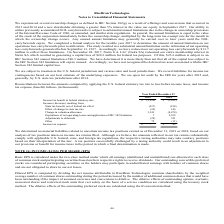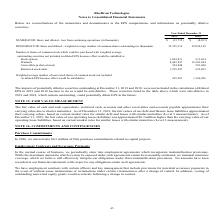From Ricebran Technologies's financial document, What are the respective basic and diluted - loss from continuing operations in 2018 and 2019? The document shows two values: 8,101 and 13,735 (in thousands). From the document: "- loss from continuing operations (in thousands) (13,735) $ (8,101) $ continuing operations (in thousands) (13,735) $ (8,101) $..." Also, What are the respective basic and diluted - weighted average number of common shares outstanding in 2018 and 2019? The document shows two values: 22,099,149 and 32,359,316 (in thousands). From the document: "mmon shares outstanding (in thousands) 32,359,316 22,099,149 umber of common shares outstanding (in thousands) 32,359,316 22,099,149..." Also, What are the respective number of stock options in 2018 and 2019? The document shows two values: 911,264 and 1,024,811 (in thousands). From the document: "Stock options 1,024,811 911,264 Stock options 1,024,811 911,264..." Also, can you calculate: What is the average number of stock options between 2018 and 2019? To answer this question, I need to perform calculations using the financial data. The calculation is: (911,264 + 1,024,811)/2 , which equals 968037.5. This is based on the information: "Stock options 1,024,811 911,264 Stock options 1,024,811 911,264..." The key data points involved are: 1,024,811, 911,264. Also, can you calculate: What is the average number of warrants between 2018 and 2019? To answer this question, I need to perform calculations using the financial data. The calculation is: (16,383,944 + 8,443,547)/2 , which equals 12413745.5. This is based on the information: "Warrants 8,443,547 16,383,944 Warrants 8,443,547 16,383,944..." The key data points involved are: 16,383,944, 8,443,547. Also, can you calculate: What is the average number of restricted stock units in 2018 and 2019? To answer this question, I need to perform calculations using the financial data. The calculation is: (623,603 + 1,235,287)/2 , which equals 929445. This is based on the information: "Restricted stock units 1,235,287 623,603 Restricted stock units 1,235,287 623,603..." The key data points involved are: 1,235,287, 623,603. 